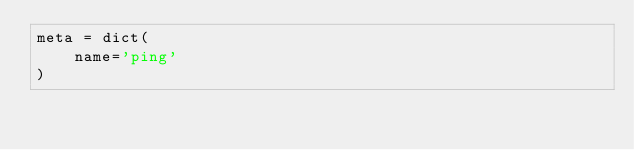<code> <loc_0><loc_0><loc_500><loc_500><_Python_>meta = dict(
    name='ping'
)
</code> 